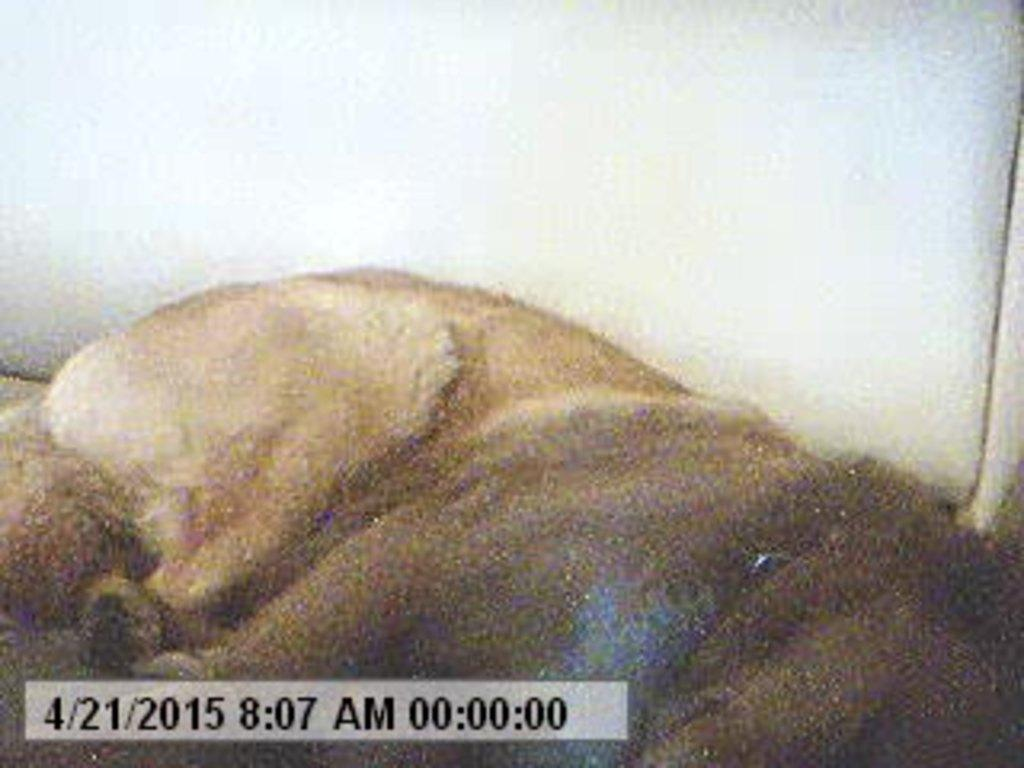What is the main subject in the foreground of the image? There is an animal lying on the ground in the foreground of the image. What can be seen in the background of the image? The background of the image is white. What type of plants can be seen growing on the mountain in the image? There is no mountain or plants present in the image; it only features an animal lying on the ground and a white background. 